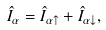<formula> <loc_0><loc_0><loc_500><loc_500>\hat { I } _ { \alpha } = \hat { I } _ { \alpha \uparrow } + \hat { I } _ { \alpha \downarrow } ,</formula> 